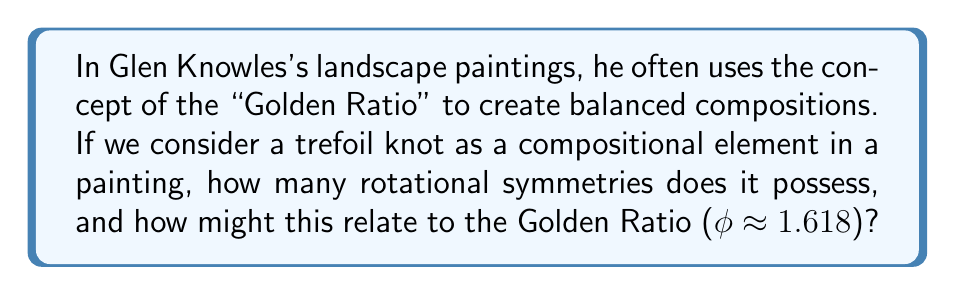Show me your answer to this math problem. To answer this question, let's break it down step-by-step:

1. First, let's recall that a trefoil knot is the simplest non-trivial knot in knot theory. It can be drawn as a continuous curve with three crossings.

2. The trefoil knot has 3-fold rotational symmetry, meaning it can be rotated by 120° (or 2π/3 radians) and appear unchanged.

3. To calculate the number of rotational symmetries:
   - A full rotation is 360° or 2π radians
   - Each symmetry rotation is 120° or 2π/3 radians
   - Number of symmetries = 360° / 120° = 3

4. Now, let's consider the Golden Ratio (φ):
   $$φ = \frac{1 + \sqrt{5}}{2} \approx 1.618$$

5. Interestingly, the Golden Ratio is related to the number 3 in several ways:
   - φ³ ≈ 4.236, which is very close to φ² + 1 = 4.236
   - The equation x³ - x - 1 = 0 has φ as its solution

6. In composition, the Golden Ratio is often used to create aesthetically pleasing divisions of space. A canvas divided according to the Golden Ratio would have proportions of approximately 1 : 1.618.

7. The trefoil knot's 3-fold symmetry could be used to create a balanced composition by placing it at the intersection of Golden Ratio divisions on the canvas, or by using its three-part structure to echo the Golden Ratio proportions in the overall layout.

This relationship between the trefoil knot's symmetry and the Golden Ratio demonstrates how mathematical concepts in knot theory can be applied to create harmonious compositions in landscape painting, much like Glen Knowles might have done in his work.
Answer: 3 rotational symmetries 